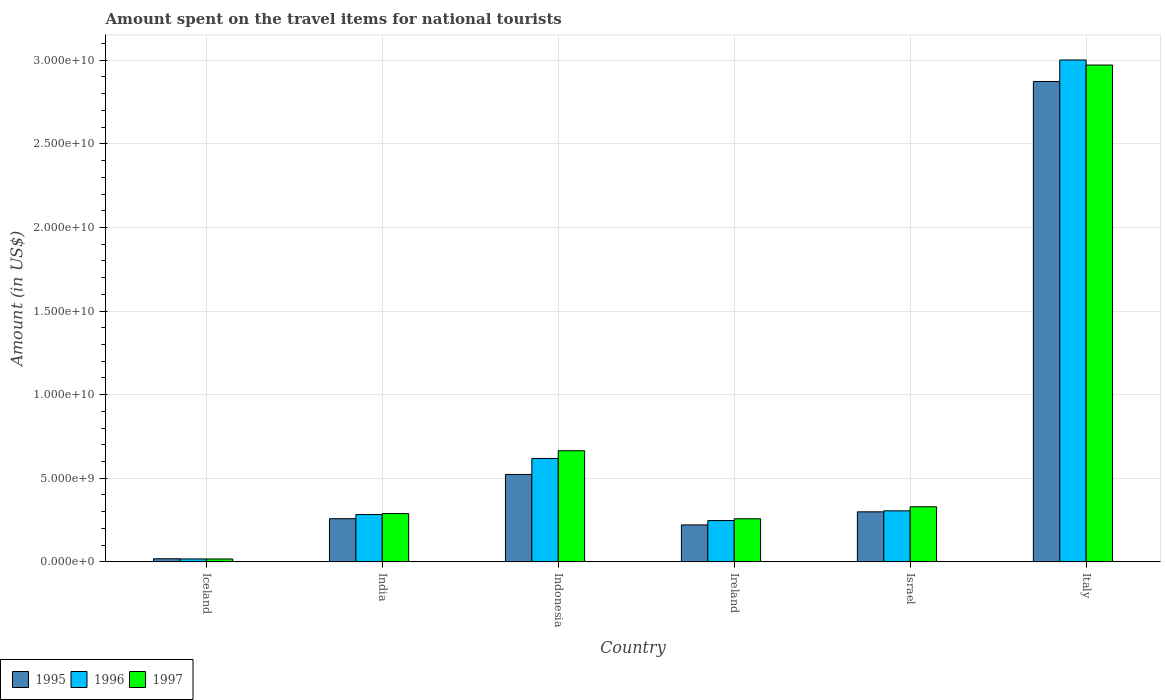How many groups of bars are there?
Ensure brevity in your answer.  6. Are the number of bars per tick equal to the number of legend labels?
Offer a terse response. Yes. Are the number of bars on each tick of the X-axis equal?
Offer a terse response. Yes. In how many cases, is the number of bars for a given country not equal to the number of legend labels?
Ensure brevity in your answer.  0. What is the amount spent on the travel items for national tourists in 1996 in Israel?
Provide a short and direct response. 3.05e+09. Across all countries, what is the maximum amount spent on the travel items for national tourists in 1996?
Provide a succinct answer. 3.00e+1. Across all countries, what is the minimum amount spent on the travel items for national tourists in 1995?
Ensure brevity in your answer.  1.86e+08. In which country was the amount spent on the travel items for national tourists in 1996 maximum?
Offer a very short reply. Italy. In which country was the amount spent on the travel items for national tourists in 1997 minimum?
Make the answer very short. Iceland. What is the total amount spent on the travel items for national tourists in 1995 in the graph?
Your response must be concise. 4.19e+1. What is the difference between the amount spent on the travel items for national tourists in 1995 in India and that in Ireland?
Provide a succinct answer. 3.71e+08. What is the difference between the amount spent on the travel items for national tourists in 1996 in Italy and the amount spent on the travel items for national tourists in 1995 in Iceland?
Your answer should be compact. 2.98e+1. What is the average amount spent on the travel items for national tourists in 1997 per country?
Keep it short and to the point. 7.55e+09. What is the difference between the amount spent on the travel items for national tourists of/in 1996 and amount spent on the travel items for national tourists of/in 1995 in Ireland?
Your answer should be compact. 2.59e+08. In how many countries, is the amount spent on the travel items for national tourists in 1996 greater than 4000000000 US$?
Make the answer very short. 2. What is the ratio of the amount spent on the travel items for national tourists in 1995 in Ireland to that in Israel?
Make the answer very short. 0.74. Is the amount spent on the travel items for national tourists in 1996 in India less than that in Italy?
Ensure brevity in your answer.  Yes. What is the difference between the highest and the second highest amount spent on the travel items for national tourists in 1996?
Offer a very short reply. 2.38e+1. What is the difference between the highest and the lowest amount spent on the travel items for national tourists in 1996?
Give a very brief answer. 2.98e+1. In how many countries, is the amount spent on the travel items for national tourists in 1997 greater than the average amount spent on the travel items for national tourists in 1997 taken over all countries?
Your answer should be very brief. 1. What does the 3rd bar from the right in Ireland represents?
Ensure brevity in your answer.  1995. How many bars are there?
Your answer should be compact. 18. Are all the bars in the graph horizontal?
Your answer should be very brief. No. How many countries are there in the graph?
Make the answer very short. 6. What is the difference between two consecutive major ticks on the Y-axis?
Ensure brevity in your answer.  5.00e+09. Does the graph contain grids?
Your answer should be very brief. Yes. Where does the legend appear in the graph?
Keep it short and to the point. Bottom left. How many legend labels are there?
Your answer should be compact. 3. What is the title of the graph?
Provide a succinct answer. Amount spent on the travel items for national tourists. What is the label or title of the X-axis?
Offer a terse response. Country. What is the Amount (in US$) in 1995 in Iceland?
Your answer should be compact. 1.86e+08. What is the Amount (in US$) of 1996 in Iceland?
Provide a succinct answer. 1.76e+08. What is the Amount (in US$) in 1997 in Iceland?
Keep it short and to the point. 1.73e+08. What is the Amount (in US$) in 1995 in India?
Your answer should be very brief. 2.58e+09. What is the Amount (in US$) of 1996 in India?
Your answer should be compact. 2.83e+09. What is the Amount (in US$) of 1997 in India?
Your answer should be compact. 2.89e+09. What is the Amount (in US$) of 1995 in Indonesia?
Offer a terse response. 5.23e+09. What is the Amount (in US$) of 1996 in Indonesia?
Ensure brevity in your answer.  6.18e+09. What is the Amount (in US$) in 1997 in Indonesia?
Provide a succinct answer. 6.65e+09. What is the Amount (in US$) in 1995 in Ireland?
Your response must be concise. 2.21e+09. What is the Amount (in US$) in 1996 in Ireland?
Offer a very short reply. 2.47e+09. What is the Amount (in US$) in 1997 in Ireland?
Your answer should be compact. 2.58e+09. What is the Amount (in US$) of 1995 in Israel?
Make the answer very short. 2.99e+09. What is the Amount (in US$) in 1996 in Israel?
Offer a terse response. 3.05e+09. What is the Amount (in US$) of 1997 in Israel?
Ensure brevity in your answer.  3.30e+09. What is the Amount (in US$) in 1995 in Italy?
Ensure brevity in your answer.  2.87e+1. What is the Amount (in US$) of 1996 in Italy?
Provide a short and direct response. 3.00e+1. What is the Amount (in US$) in 1997 in Italy?
Provide a succinct answer. 2.97e+1. Across all countries, what is the maximum Amount (in US$) of 1995?
Provide a succinct answer. 2.87e+1. Across all countries, what is the maximum Amount (in US$) in 1996?
Your answer should be very brief. 3.00e+1. Across all countries, what is the maximum Amount (in US$) in 1997?
Offer a terse response. 2.97e+1. Across all countries, what is the minimum Amount (in US$) of 1995?
Offer a terse response. 1.86e+08. Across all countries, what is the minimum Amount (in US$) of 1996?
Offer a very short reply. 1.76e+08. Across all countries, what is the minimum Amount (in US$) of 1997?
Give a very brief answer. 1.73e+08. What is the total Amount (in US$) in 1995 in the graph?
Ensure brevity in your answer.  4.19e+1. What is the total Amount (in US$) of 1996 in the graph?
Give a very brief answer. 4.47e+1. What is the total Amount (in US$) in 1997 in the graph?
Give a very brief answer. 4.53e+1. What is the difference between the Amount (in US$) of 1995 in Iceland and that in India?
Provide a short and direct response. -2.40e+09. What is the difference between the Amount (in US$) of 1996 in Iceland and that in India?
Your answer should be compact. -2.66e+09. What is the difference between the Amount (in US$) in 1997 in Iceland and that in India?
Make the answer very short. -2.72e+09. What is the difference between the Amount (in US$) of 1995 in Iceland and that in Indonesia?
Provide a succinct answer. -5.04e+09. What is the difference between the Amount (in US$) in 1996 in Iceland and that in Indonesia?
Your answer should be compact. -6.01e+09. What is the difference between the Amount (in US$) of 1997 in Iceland and that in Indonesia?
Ensure brevity in your answer.  -6.48e+09. What is the difference between the Amount (in US$) of 1995 in Iceland and that in Ireland?
Offer a terse response. -2.02e+09. What is the difference between the Amount (in US$) of 1996 in Iceland and that in Ireland?
Offer a very short reply. -2.29e+09. What is the difference between the Amount (in US$) in 1997 in Iceland and that in Ireland?
Provide a short and direct response. -2.40e+09. What is the difference between the Amount (in US$) in 1995 in Iceland and that in Israel?
Keep it short and to the point. -2.81e+09. What is the difference between the Amount (in US$) in 1996 in Iceland and that in Israel?
Give a very brief answer. -2.88e+09. What is the difference between the Amount (in US$) in 1997 in Iceland and that in Israel?
Ensure brevity in your answer.  -3.12e+09. What is the difference between the Amount (in US$) in 1995 in Iceland and that in Italy?
Keep it short and to the point. -2.85e+1. What is the difference between the Amount (in US$) in 1996 in Iceland and that in Italy?
Give a very brief answer. -2.98e+1. What is the difference between the Amount (in US$) in 1997 in Iceland and that in Italy?
Offer a very short reply. -2.95e+1. What is the difference between the Amount (in US$) of 1995 in India and that in Indonesia?
Provide a short and direct response. -2.65e+09. What is the difference between the Amount (in US$) in 1996 in India and that in Indonesia?
Your answer should be very brief. -3.35e+09. What is the difference between the Amount (in US$) in 1997 in India and that in Indonesia?
Your answer should be very brief. -3.76e+09. What is the difference between the Amount (in US$) in 1995 in India and that in Ireland?
Provide a short and direct response. 3.71e+08. What is the difference between the Amount (in US$) of 1996 in India and that in Ireland?
Your answer should be compact. 3.61e+08. What is the difference between the Amount (in US$) in 1997 in India and that in Ireland?
Keep it short and to the point. 3.12e+08. What is the difference between the Amount (in US$) of 1995 in India and that in Israel?
Offer a terse response. -4.11e+08. What is the difference between the Amount (in US$) of 1996 in India and that in Israel?
Provide a succinct answer. -2.22e+08. What is the difference between the Amount (in US$) in 1997 in India and that in Israel?
Your answer should be compact. -4.05e+08. What is the difference between the Amount (in US$) of 1995 in India and that in Italy?
Provide a short and direct response. -2.61e+1. What is the difference between the Amount (in US$) of 1996 in India and that in Italy?
Ensure brevity in your answer.  -2.72e+1. What is the difference between the Amount (in US$) in 1997 in India and that in Italy?
Offer a very short reply. -2.68e+1. What is the difference between the Amount (in US$) in 1995 in Indonesia and that in Ireland?
Your response must be concise. 3.02e+09. What is the difference between the Amount (in US$) of 1996 in Indonesia and that in Ireland?
Give a very brief answer. 3.71e+09. What is the difference between the Amount (in US$) in 1997 in Indonesia and that in Ireland?
Provide a short and direct response. 4.07e+09. What is the difference between the Amount (in US$) in 1995 in Indonesia and that in Israel?
Make the answer very short. 2.24e+09. What is the difference between the Amount (in US$) of 1996 in Indonesia and that in Israel?
Make the answer very short. 3.13e+09. What is the difference between the Amount (in US$) in 1997 in Indonesia and that in Israel?
Ensure brevity in your answer.  3.35e+09. What is the difference between the Amount (in US$) of 1995 in Indonesia and that in Italy?
Your answer should be compact. -2.35e+1. What is the difference between the Amount (in US$) of 1996 in Indonesia and that in Italy?
Your answer should be very brief. -2.38e+1. What is the difference between the Amount (in US$) of 1997 in Indonesia and that in Italy?
Give a very brief answer. -2.31e+1. What is the difference between the Amount (in US$) in 1995 in Ireland and that in Israel?
Ensure brevity in your answer.  -7.82e+08. What is the difference between the Amount (in US$) in 1996 in Ireland and that in Israel?
Your answer should be very brief. -5.83e+08. What is the difference between the Amount (in US$) of 1997 in Ireland and that in Israel?
Provide a short and direct response. -7.17e+08. What is the difference between the Amount (in US$) in 1995 in Ireland and that in Italy?
Provide a succinct answer. -2.65e+1. What is the difference between the Amount (in US$) in 1996 in Ireland and that in Italy?
Keep it short and to the point. -2.75e+1. What is the difference between the Amount (in US$) of 1997 in Ireland and that in Italy?
Offer a terse response. -2.71e+1. What is the difference between the Amount (in US$) of 1995 in Israel and that in Italy?
Ensure brevity in your answer.  -2.57e+1. What is the difference between the Amount (in US$) in 1996 in Israel and that in Italy?
Give a very brief answer. -2.70e+1. What is the difference between the Amount (in US$) in 1997 in Israel and that in Italy?
Make the answer very short. -2.64e+1. What is the difference between the Amount (in US$) in 1995 in Iceland and the Amount (in US$) in 1996 in India?
Provide a succinct answer. -2.64e+09. What is the difference between the Amount (in US$) of 1995 in Iceland and the Amount (in US$) of 1997 in India?
Make the answer very short. -2.70e+09. What is the difference between the Amount (in US$) of 1996 in Iceland and the Amount (in US$) of 1997 in India?
Give a very brief answer. -2.71e+09. What is the difference between the Amount (in US$) of 1995 in Iceland and the Amount (in US$) of 1996 in Indonesia?
Give a very brief answer. -6.00e+09. What is the difference between the Amount (in US$) of 1995 in Iceland and the Amount (in US$) of 1997 in Indonesia?
Keep it short and to the point. -6.46e+09. What is the difference between the Amount (in US$) in 1996 in Iceland and the Amount (in US$) in 1997 in Indonesia?
Your response must be concise. -6.47e+09. What is the difference between the Amount (in US$) in 1995 in Iceland and the Amount (in US$) in 1996 in Ireland?
Your response must be concise. -2.28e+09. What is the difference between the Amount (in US$) in 1995 in Iceland and the Amount (in US$) in 1997 in Ireland?
Provide a short and direct response. -2.39e+09. What is the difference between the Amount (in US$) of 1996 in Iceland and the Amount (in US$) of 1997 in Ireland?
Provide a short and direct response. -2.40e+09. What is the difference between the Amount (in US$) of 1995 in Iceland and the Amount (in US$) of 1996 in Israel?
Ensure brevity in your answer.  -2.87e+09. What is the difference between the Amount (in US$) of 1995 in Iceland and the Amount (in US$) of 1997 in Israel?
Make the answer very short. -3.11e+09. What is the difference between the Amount (in US$) in 1996 in Iceland and the Amount (in US$) in 1997 in Israel?
Ensure brevity in your answer.  -3.12e+09. What is the difference between the Amount (in US$) in 1995 in Iceland and the Amount (in US$) in 1996 in Italy?
Provide a short and direct response. -2.98e+1. What is the difference between the Amount (in US$) of 1995 in Iceland and the Amount (in US$) of 1997 in Italy?
Give a very brief answer. -2.95e+1. What is the difference between the Amount (in US$) in 1996 in Iceland and the Amount (in US$) in 1997 in Italy?
Offer a terse response. -2.95e+1. What is the difference between the Amount (in US$) in 1995 in India and the Amount (in US$) in 1996 in Indonesia?
Keep it short and to the point. -3.60e+09. What is the difference between the Amount (in US$) in 1995 in India and the Amount (in US$) in 1997 in Indonesia?
Ensure brevity in your answer.  -4.07e+09. What is the difference between the Amount (in US$) in 1996 in India and the Amount (in US$) in 1997 in Indonesia?
Your answer should be compact. -3.82e+09. What is the difference between the Amount (in US$) of 1995 in India and the Amount (in US$) of 1996 in Ireland?
Keep it short and to the point. 1.12e+08. What is the difference between the Amount (in US$) in 1995 in India and the Amount (in US$) in 1997 in Ireland?
Your answer should be very brief. 4.00e+06. What is the difference between the Amount (in US$) of 1996 in India and the Amount (in US$) of 1997 in Ireland?
Your answer should be very brief. 2.53e+08. What is the difference between the Amount (in US$) in 1995 in India and the Amount (in US$) in 1996 in Israel?
Give a very brief answer. -4.71e+08. What is the difference between the Amount (in US$) in 1995 in India and the Amount (in US$) in 1997 in Israel?
Give a very brief answer. -7.13e+08. What is the difference between the Amount (in US$) of 1996 in India and the Amount (in US$) of 1997 in Israel?
Offer a very short reply. -4.64e+08. What is the difference between the Amount (in US$) of 1995 in India and the Amount (in US$) of 1996 in Italy?
Your answer should be compact. -2.74e+1. What is the difference between the Amount (in US$) of 1995 in India and the Amount (in US$) of 1997 in Italy?
Provide a short and direct response. -2.71e+1. What is the difference between the Amount (in US$) of 1996 in India and the Amount (in US$) of 1997 in Italy?
Keep it short and to the point. -2.69e+1. What is the difference between the Amount (in US$) in 1995 in Indonesia and the Amount (in US$) in 1996 in Ireland?
Provide a short and direct response. 2.76e+09. What is the difference between the Amount (in US$) of 1995 in Indonesia and the Amount (in US$) of 1997 in Ireland?
Offer a terse response. 2.65e+09. What is the difference between the Amount (in US$) of 1996 in Indonesia and the Amount (in US$) of 1997 in Ireland?
Keep it short and to the point. 3.61e+09. What is the difference between the Amount (in US$) of 1995 in Indonesia and the Amount (in US$) of 1996 in Israel?
Your answer should be very brief. 2.18e+09. What is the difference between the Amount (in US$) in 1995 in Indonesia and the Amount (in US$) in 1997 in Israel?
Your answer should be very brief. 1.93e+09. What is the difference between the Amount (in US$) of 1996 in Indonesia and the Amount (in US$) of 1997 in Israel?
Make the answer very short. 2.89e+09. What is the difference between the Amount (in US$) of 1995 in Indonesia and the Amount (in US$) of 1996 in Italy?
Provide a short and direct response. -2.48e+1. What is the difference between the Amount (in US$) in 1995 in Indonesia and the Amount (in US$) in 1997 in Italy?
Keep it short and to the point. -2.45e+1. What is the difference between the Amount (in US$) of 1996 in Indonesia and the Amount (in US$) of 1997 in Italy?
Provide a succinct answer. -2.35e+1. What is the difference between the Amount (in US$) of 1995 in Ireland and the Amount (in US$) of 1996 in Israel?
Keep it short and to the point. -8.42e+08. What is the difference between the Amount (in US$) of 1995 in Ireland and the Amount (in US$) of 1997 in Israel?
Make the answer very short. -1.08e+09. What is the difference between the Amount (in US$) of 1996 in Ireland and the Amount (in US$) of 1997 in Israel?
Provide a succinct answer. -8.25e+08. What is the difference between the Amount (in US$) in 1995 in Ireland and the Amount (in US$) in 1996 in Italy?
Provide a short and direct response. -2.78e+1. What is the difference between the Amount (in US$) in 1995 in Ireland and the Amount (in US$) in 1997 in Italy?
Your response must be concise. -2.75e+1. What is the difference between the Amount (in US$) of 1996 in Ireland and the Amount (in US$) of 1997 in Italy?
Make the answer very short. -2.72e+1. What is the difference between the Amount (in US$) in 1995 in Israel and the Amount (in US$) in 1996 in Italy?
Your answer should be very brief. -2.70e+1. What is the difference between the Amount (in US$) of 1995 in Israel and the Amount (in US$) of 1997 in Italy?
Ensure brevity in your answer.  -2.67e+1. What is the difference between the Amount (in US$) in 1996 in Israel and the Amount (in US$) in 1997 in Italy?
Offer a terse response. -2.67e+1. What is the average Amount (in US$) in 1995 per country?
Offer a terse response. 6.99e+09. What is the average Amount (in US$) in 1996 per country?
Give a very brief answer. 7.46e+09. What is the average Amount (in US$) of 1997 per country?
Provide a short and direct response. 7.55e+09. What is the difference between the Amount (in US$) in 1995 and Amount (in US$) in 1997 in Iceland?
Provide a short and direct response. 1.30e+07. What is the difference between the Amount (in US$) in 1996 and Amount (in US$) in 1997 in Iceland?
Your answer should be compact. 3.00e+06. What is the difference between the Amount (in US$) in 1995 and Amount (in US$) in 1996 in India?
Your response must be concise. -2.49e+08. What is the difference between the Amount (in US$) in 1995 and Amount (in US$) in 1997 in India?
Ensure brevity in your answer.  -3.08e+08. What is the difference between the Amount (in US$) of 1996 and Amount (in US$) of 1997 in India?
Offer a very short reply. -5.90e+07. What is the difference between the Amount (in US$) of 1995 and Amount (in US$) of 1996 in Indonesia?
Give a very brief answer. -9.55e+08. What is the difference between the Amount (in US$) of 1995 and Amount (in US$) of 1997 in Indonesia?
Offer a terse response. -1.42e+09. What is the difference between the Amount (in US$) in 1996 and Amount (in US$) in 1997 in Indonesia?
Ensure brevity in your answer.  -4.64e+08. What is the difference between the Amount (in US$) in 1995 and Amount (in US$) in 1996 in Ireland?
Your answer should be compact. -2.59e+08. What is the difference between the Amount (in US$) in 1995 and Amount (in US$) in 1997 in Ireland?
Your response must be concise. -3.67e+08. What is the difference between the Amount (in US$) of 1996 and Amount (in US$) of 1997 in Ireland?
Ensure brevity in your answer.  -1.08e+08. What is the difference between the Amount (in US$) in 1995 and Amount (in US$) in 1996 in Israel?
Provide a succinct answer. -6.00e+07. What is the difference between the Amount (in US$) in 1995 and Amount (in US$) in 1997 in Israel?
Ensure brevity in your answer.  -3.02e+08. What is the difference between the Amount (in US$) of 1996 and Amount (in US$) of 1997 in Israel?
Offer a very short reply. -2.42e+08. What is the difference between the Amount (in US$) of 1995 and Amount (in US$) of 1996 in Italy?
Provide a succinct answer. -1.29e+09. What is the difference between the Amount (in US$) of 1995 and Amount (in US$) of 1997 in Italy?
Give a very brief answer. -9.83e+08. What is the difference between the Amount (in US$) of 1996 and Amount (in US$) of 1997 in Italy?
Your answer should be very brief. 3.03e+08. What is the ratio of the Amount (in US$) in 1995 in Iceland to that in India?
Provide a short and direct response. 0.07. What is the ratio of the Amount (in US$) of 1996 in Iceland to that in India?
Provide a short and direct response. 0.06. What is the ratio of the Amount (in US$) in 1997 in Iceland to that in India?
Your response must be concise. 0.06. What is the ratio of the Amount (in US$) in 1995 in Iceland to that in Indonesia?
Make the answer very short. 0.04. What is the ratio of the Amount (in US$) in 1996 in Iceland to that in Indonesia?
Give a very brief answer. 0.03. What is the ratio of the Amount (in US$) in 1997 in Iceland to that in Indonesia?
Make the answer very short. 0.03. What is the ratio of the Amount (in US$) in 1995 in Iceland to that in Ireland?
Make the answer very short. 0.08. What is the ratio of the Amount (in US$) in 1996 in Iceland to that in Ireland?
Provide a short and direct response. 0.07. What is the ratio of the Amount (in US$) in 1997 in Iceland to that in Ireland?
Your answer should be compact. 0.07. What is the ratio of the Amount (in US$) of 1995 in Iceland to that in Israel?
Your answer should be very brief. 0.06. What is the ratio of the Amount (in US$) in 1996 in Iceland to that in Israel?
Keep it short and to the point. 0.06. What is the ratio of the Amount (in US$) in 1997 in Iceland to that in Israel?
Keep it short and to the point. 0.05. What is the ratio of the Amount (in US$) in 1995 in Iceland to that in Italy?
Your answer should be compact. 0.01. What is the ratio of the Amount (in US$) of 1996 in Iceland to that in Italy?
Offer a terse response. 0.01. What is the ratio of the Amount (in US$) in 1997 in Iceland to that in Italy?
Your answer should be very brief. 0.01. What is the ratio of the Amount (in US$) of 1995 in India to that in Indonesia?
Your answer should be compact. 0.49. What is the ratio of the Amount (in US$) of 1996 in India to that in Indonesia?
Provide a succinct answer. 0.46. What is the ratio of the Amount (in US$) in 1997 in India to that in Indonesia?
Offer a very short reply. 0.43. What is the ratio of the Amount (in US$) of 1995 in India to that in Ireland?
Your answer should be very brief. 1.17. What is the ratio of the Amount (in US$) of 1996 in India to that in Ireland?
Offer a very short reply. 1.15. What is the ratio of the Amount (in US$) in 1997 in India to that in Ireland?
Provide a short and direct response. 1.12. What is the ratio of the Amount (in US$) of 1995 in India to that in Israel?
Provide a short and direct response. 0.86. What is the ratio of the Amount (in US$) in 1996 in India to that in Israel?
Offer a terse response. 0.93. What is the ratio of the Amount (in US$) in 1997 in India to that in Israel?
Your answer should be very brief. 0.88. What is the ratio of the Amount (in US$) in 1995 in India to that in Italy?
Offer a very short reply. 0.09. What is the ratio of the Amount (in US$) in 1996 in India to that in Italy?
Provide a succinct answer. 0.09. What is the ratio of the Amount (in US$) of 1997 in India to that in Italy?
Your answer should be compact. 0.1. What is the ratio of the Amount (in US$) of 1995 in Indonesia to that in Ireland?
Your response must be concise. 2.37. What is the ratio of the Amount (in US$) of 1996 in Indonesia to that in Ireland?
Keep it short and to the point. 2.5. What is the ratio of the Amount (in US$) of 1997 in Indonesia to that in Ireland?
Give a very brief answer. 2.58. What is the ratio of the Amount (in US$) in 1995 in Indonesia to that in Israel?
Your answer should be very brief. 1.75. What is the ratio of the Amount (in US$) in 1996 in Indonesia to that in Israel?
Your answer should be compact. 2.03. What is the ratio of the Amount (in US$) of 1997 in Indonesia to that in Israel?
Offer a terse response. 2.02. What is the ratio of the Amount (in US$) of 1995 in Indonesia to that in Italy?
Your response must be concise. 0.18. What is the ratio of the Amount (in US$) in 1996 in Indonesia to that in Italy?
Offer a terse response. 0.21. What is the ratio of the Amount (in US$) in 1997 in Indonesia to that in Italy?
Provide a succinct answer. 0.22. What is the ratio of the Amount (in US$) of 1995 in Ireland to that in Israel?
Provide a succinct answer. 0.74. What is the ratio of the Amount (in US$) of 1996 in Ireland to that in Israel?
Keep it short and to the point. 0.81. What is the ratio of the Amount (in US$) of 1997 in Ireland to that in Israel?
Offer a very short reply. 0.78. What is the ratio of the Amount (in US$) of 1995 in Ireland to that in Italy?
Give a very brief answer. 0.08. What is the ratio of the Amount (in US$) of 1996 in Ireland to that in Italy?
Provide a short and direct response. 0.08. What is the ratio of the Amount (in US$) of 1997 in Ireland to that in Italy?
Offer a terse response. 0.09. What is the ratio of the Amount (in US$) of 1995 in Israel to that in Italy?
Provide a succinct answer. 0.1. What is the ratio of the Amount (in US$) of 1996 in Israel to that in Italy?
Offer a very short reply. 0.1. What is the ratio of the Amount (in US$) of 1997 in Israel to that in Italy?
Make the answer very short. 0.11. What is the difference between the highest and the second highest Amount (in US$) of 1995?
Make the answer very short. 2.35e+1. What is the difference between the highest and the second highest Amount (in US$) in 1996?
Make the answer very short. 2.38e+1. What is the difference between the highest and the second highest Amount (in US$) in 1997?
Keep it short and to the point. 2.31e+1. What is the difference between the highest and the lowest Amount (in US$) of 1995?
Provide a short and direct response. 2.85e+1. What is the difference between the highest and the lowest Amount (in US$) of 1996?
Offer a terse response. 2.98e+1. What is the difference between the highest and the lowest Amount (in US$) of 1997?
Your response must be concise. 2.95e+1. 